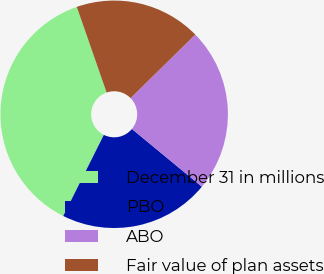Convert chart to OTSL. <chart><loc_0><loc_0><loc_500><loc_500><pie_chart><fcel>December 31 in millions<fcel>PBO<fcel>ABO<fcel>Fair value of plan assets<nl><fcel>37.28%<fcel>21.41%<fcel>23.34%<fcel>17.97%<nl></chart> 